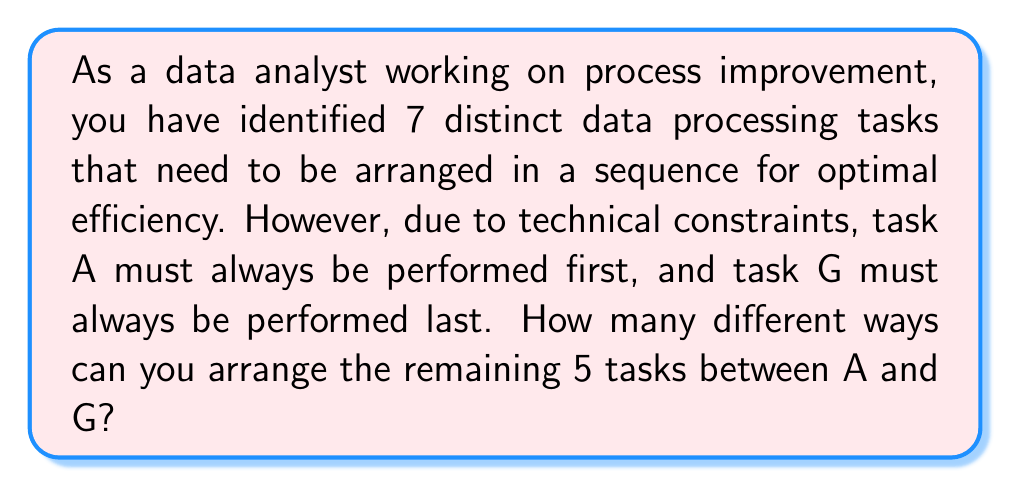Could you help me with this problem? Let's approach this step-by-step:

1) We have 7 tasks in total, but the positions of 2 tasks (A and G) are fixed.

2) This means we only need to arrange the remaining 5 tasks (let's call them B, C, D, E, and F) in the 5 positions between A and G.

3) This is a straightforward permutation problem. We are arranging 5 distinct objects in 5 distinct positions.

4) The number of permutations of n distinct objects is given by the formula:

   $$P(n) = n!$$

   Where $n!$ represents the factorial of n.

5) In this case, $n = 5$, so we need to calculate $5!$

6) Let's expand this:

   $$5! = 5 \times 4 \times 3 \times 2 \times 1 = 120$$

Therefore, there are 120 different ways to arrange the 5 tasks between A and G.
Answer: $120$ ways 